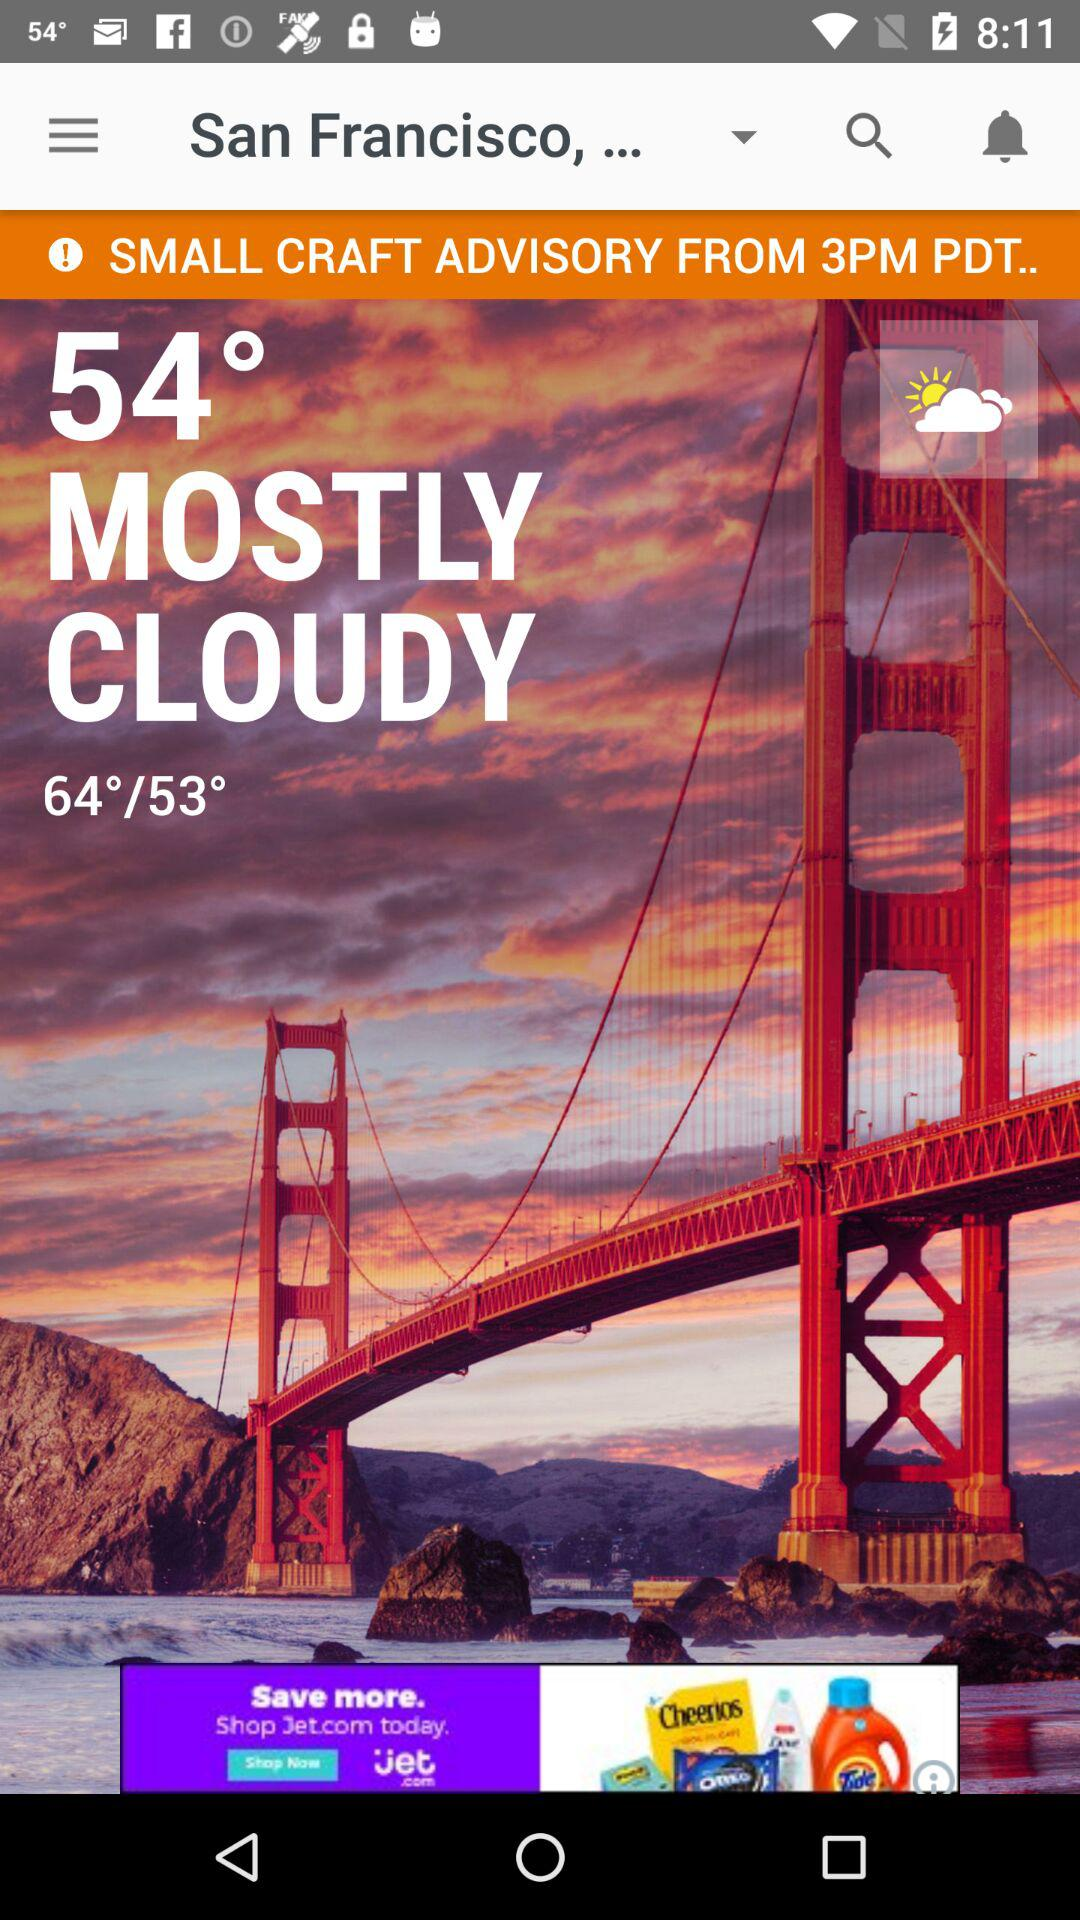How's the weather? The weather is mostly cloudy. 